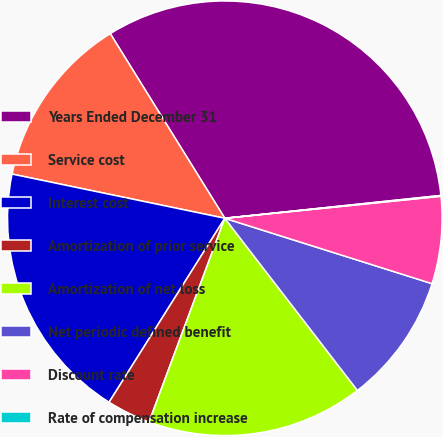Convert chart to OTSL. <chart><loc_0><loc_0><loc_500><loc_500><pie_chart><fcel>Years Ended December 31<fcel>Service cost<fcel>Interest cost<fcel>Amortization of prior service<fcel>Amortization of net loss<fcel>Net periodic defined benefit<fcel>Discount rate<fcel>Rate of compensation increase<nl><fcel>32.16%<fcel>12.9%<fcel>19.32%<fcel>3.27%<fcel>16.11%<fcel>9.69%<fcel>6.48%<fcel>0.06%<nl></chart> 